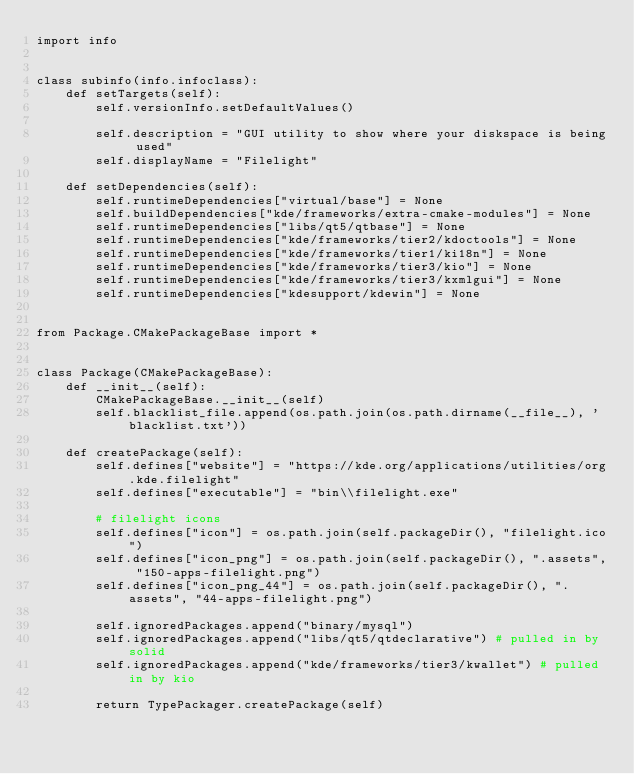Convert code to text. <code><loc_0><loc_0><loc_500><loc_500><_Python_>import info


class subinfo(info.infoclass):
    def setTargets(self):
        self.versionInfo.setDefaultValues()

        self.description = "GUI utility to show where your diskspace is being used"
        self.displayName = "Filelight"

    def setDependencies(self):
        self.runtimeDependencies["virtual/base"] = None
        self.buildDependencies["kde/frameworks/extra-cmake-modules"] = None
        self.runtimeDependencies["libs/qt5/qtbase"] = None
        self.runtimeDependencies["kde/frameworks/tier2/kdoctools"] = None
        self.runtimeDependencies["kde/frameworks/tier1/ki18n"] = None
        self.runtimeDependencies["kde/frameworks/tier3/kio"] = None
        self.runtimeDependencies["kde/frameworks/tier3/kxmlgui"] = None
        self.runtimeDependencies["kdesupport/kdewin"] = None


from Package.CMakePackageBase import *


class Package(CMakePackageBase):
    def __init__(self):
        CMakePackageBase.__init__(self)
        self.blacklist_file.append(os.path.join(os.path.dirname(__file__), 'blacklist.txt'))

    def createPackage(self):
        self.defines["website"] = "https://kde.org/applications/utilities/org.kde.filelight"
        self.defines["executable"] = "bin\\filelight.exe"

        # filelight icons
        self.defines["icon"] = os.path.join(self.packageDir(), "filelight.ico")
        self.defines["icon_png"] = os.path.join(self.packageDir(), ".assets", "150-apps-filelight.png")
        self.defines["icon_png_44"] = os.path.join(self.packageDir(), ".assets", "44-apps-filelight.png")

        self.ignoredPackages.append("binary/mysql")
        self.ignoredPackages.append("libs/qt5/qtdeclarative") # pulled in by solid
        self.ignoredPackages.append("kde/frameworks/tier3/kwallet") # pulled in by kio

        return TypePackager.createPackage(self)
</code> 